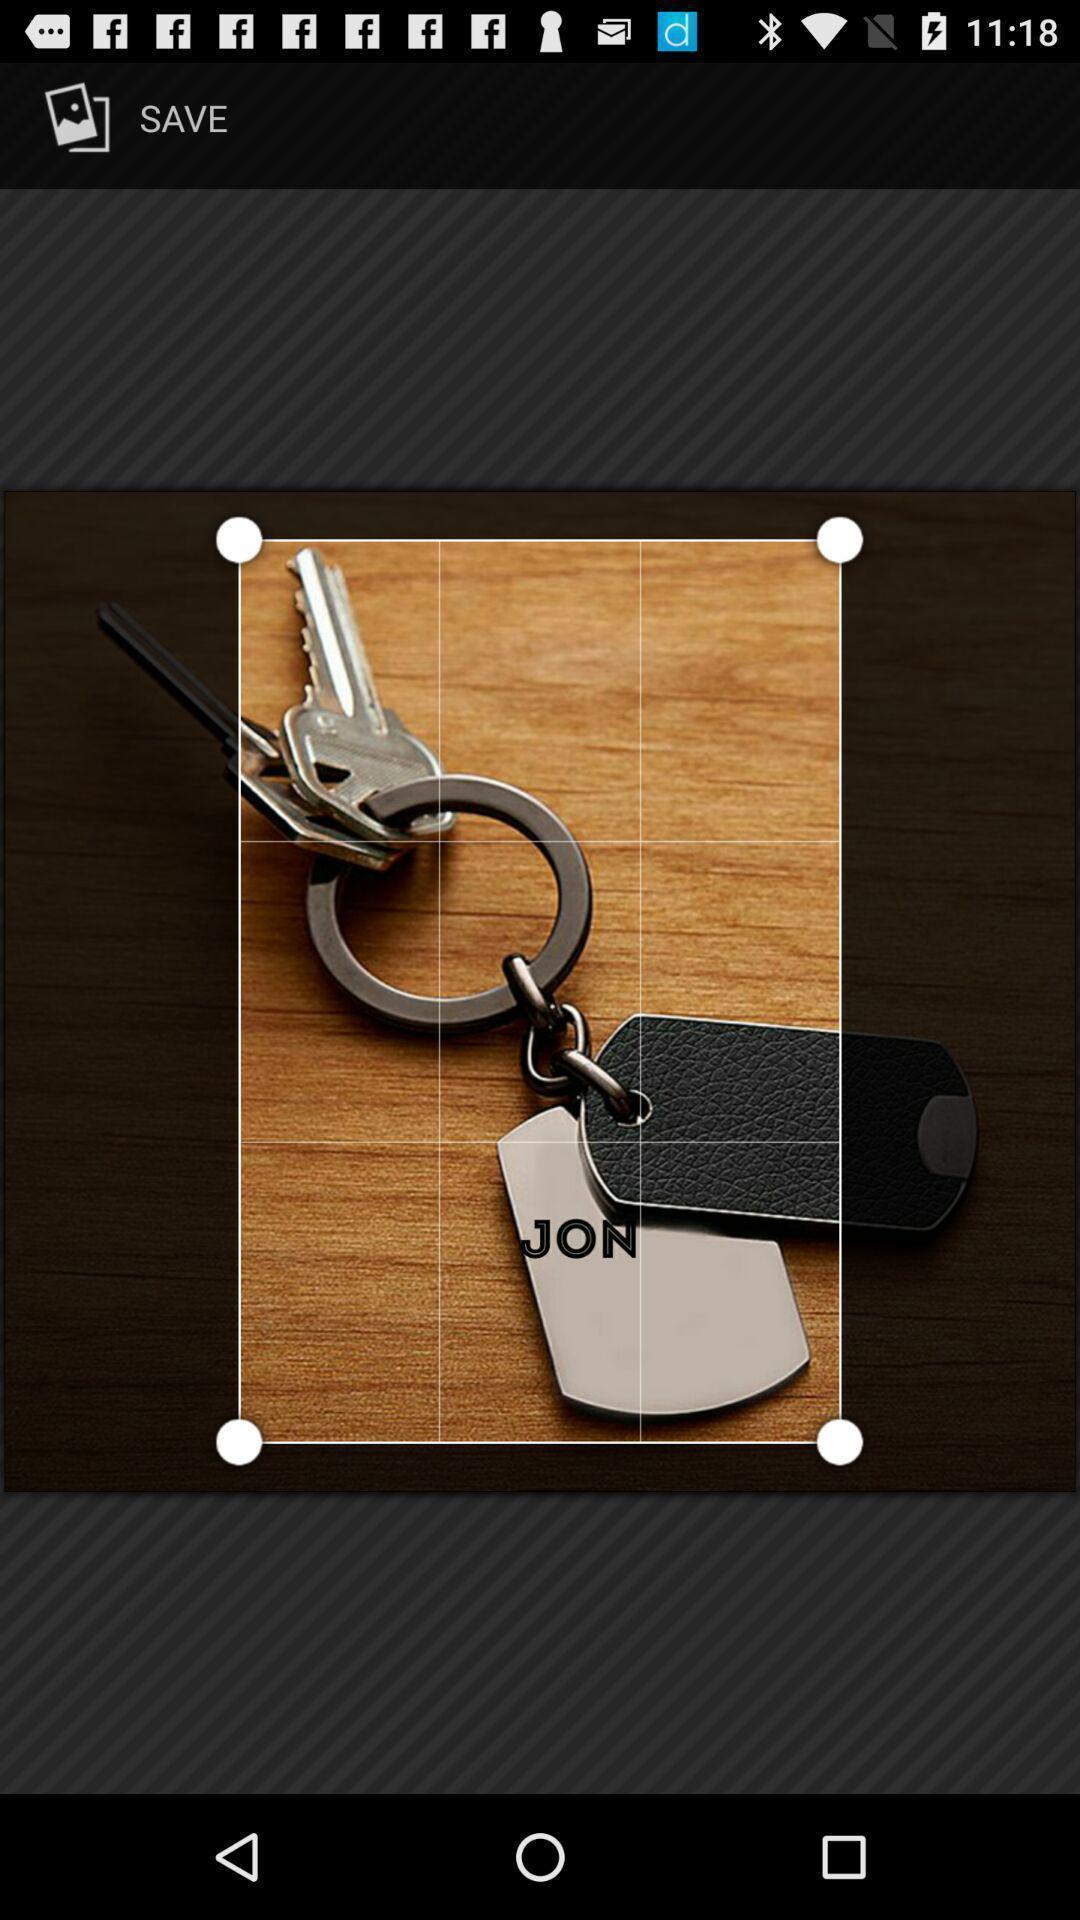Provide a textual representation of this image. Screen showing an image with crop option. 